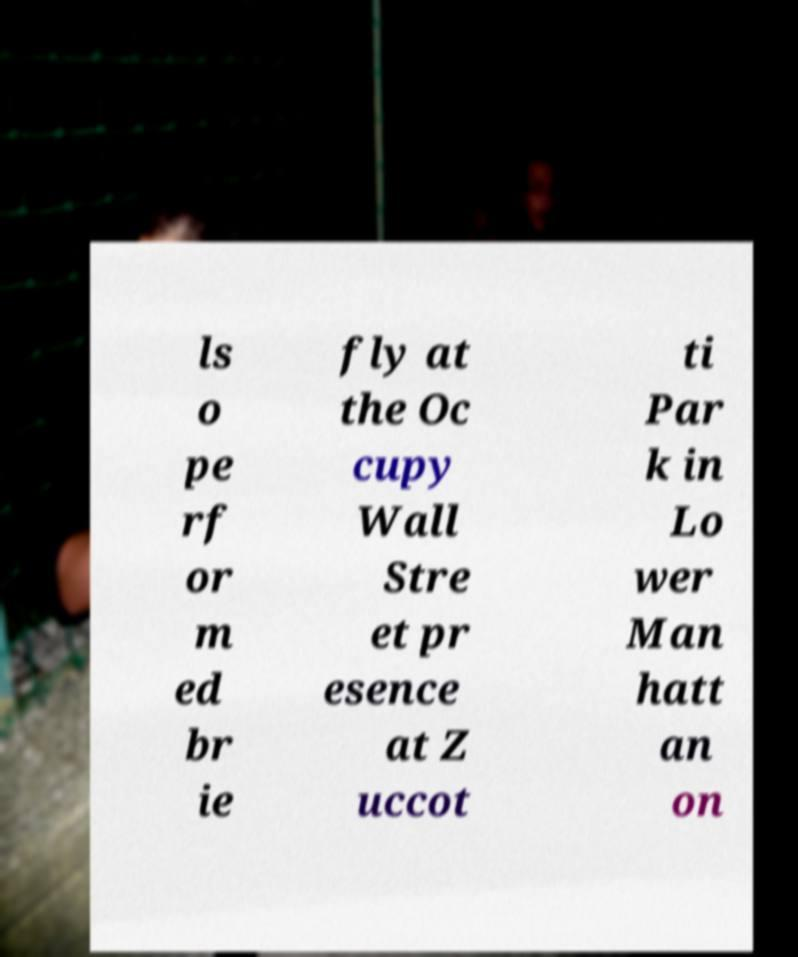Could you extract and type out the text from this image? ls o pe rf or m ed br ie fly at the Oc cupy Wall Stre et pr esence at Z uccot ti Par k in Lo wer Man hatt an on 